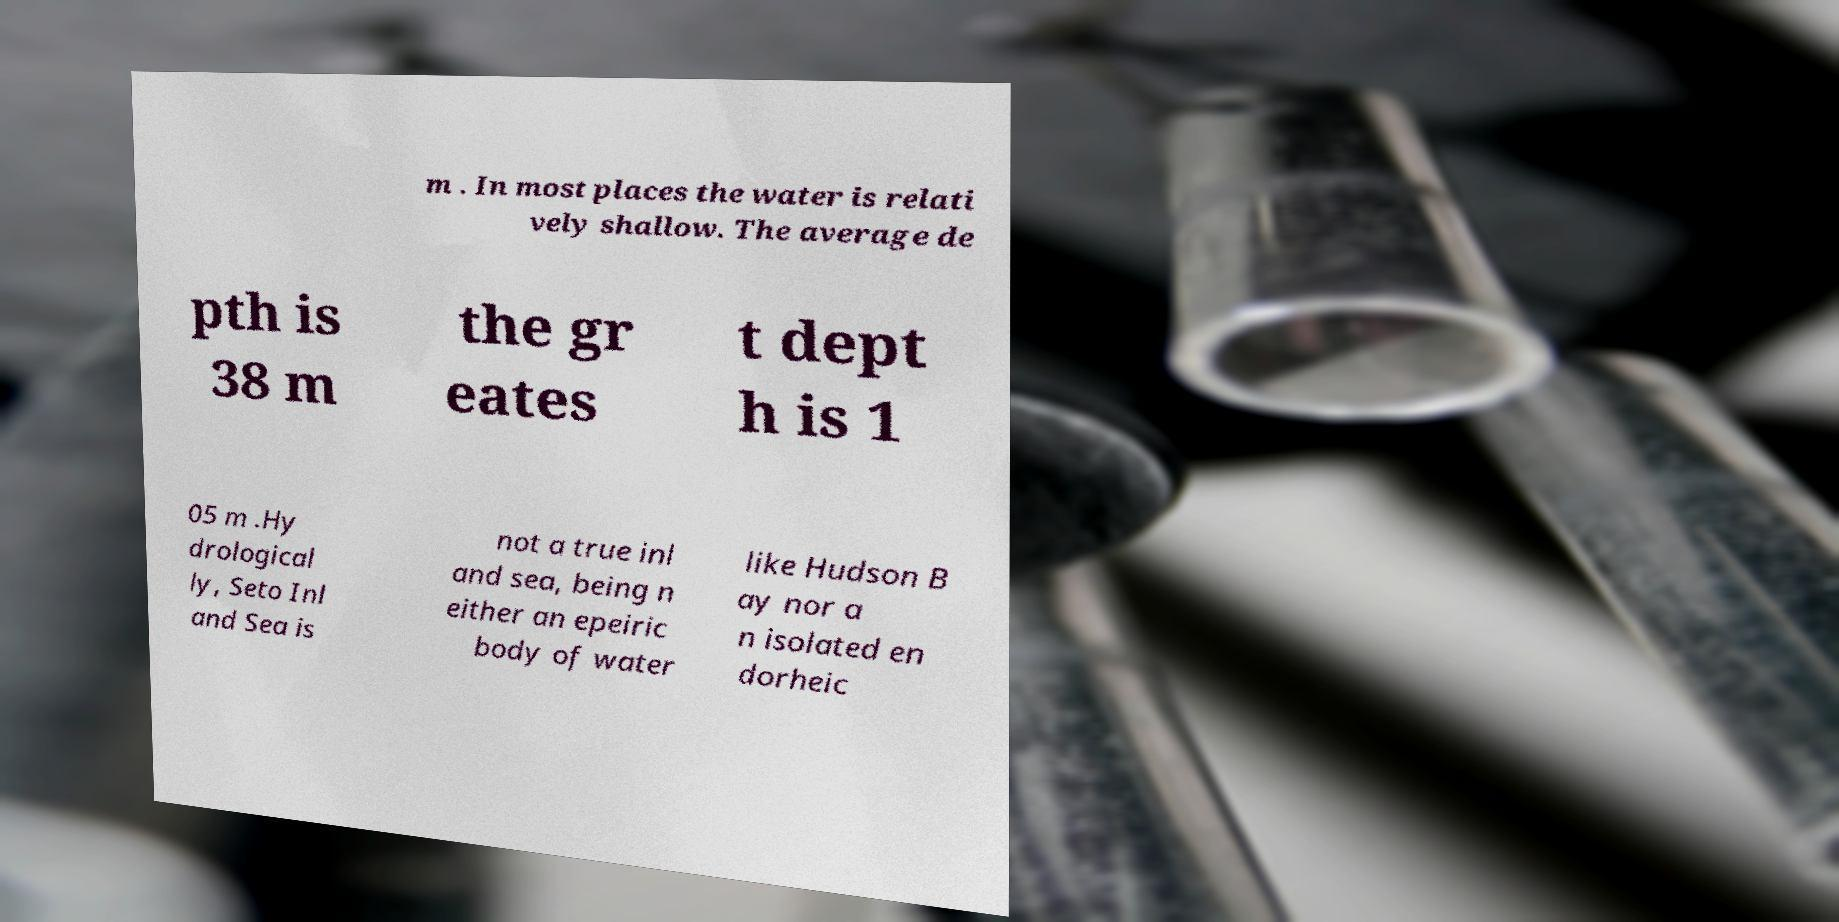Could you assist in decoding the text presented in this image and type it out clearly? m . In most places the water is relati vely shallow. The average de pth is 38 m the gr eates t dept h is 1 05 m .Hy drological ly, Seto Inl and Sea is not a true inl and sea, being n either an epeiric body of water like Hudson B ay nor a n isolated en dorheic 